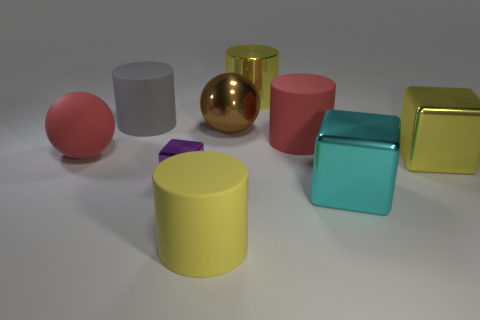What number of other things are the same size as the red rubber ball?
Give a very brief answer. 7. Do the cyan block and the red thing to the right of the big matte ball have the same material?
Offer a very short reply. No. How many objects are either blocks to the right of the brown ball or big rubber cylinders behind the rubber ball?
Provide a short and direct response. 4. What is the color of the tiny shiny object?
Your answer should be very brief. Purple. Are there fewer metallic cubes right of the tiny metallic block than large metal objects?
Provide a succinct answer. Yes. Are any cyan metallic balls visible?
Give a very brief answer. No. Is the number of big brown balls less than the number of large objects?
Provide a short and direct response. Yes. What number of big things are made of the same material as the small block?
Provide a short and direct response. 4. The large cylinder that is made of the same material as the purple cube is what color?
Your answer should be very brief. Yellow. What is the shape of the large gray thing?
Provide a short and direct response. Cylinder. 